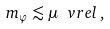<formula> <loc_0><loc_0><loc_500><loc_500>m _ { \varphi } \lesssim \mu \ v r e l \, ,</formula> 